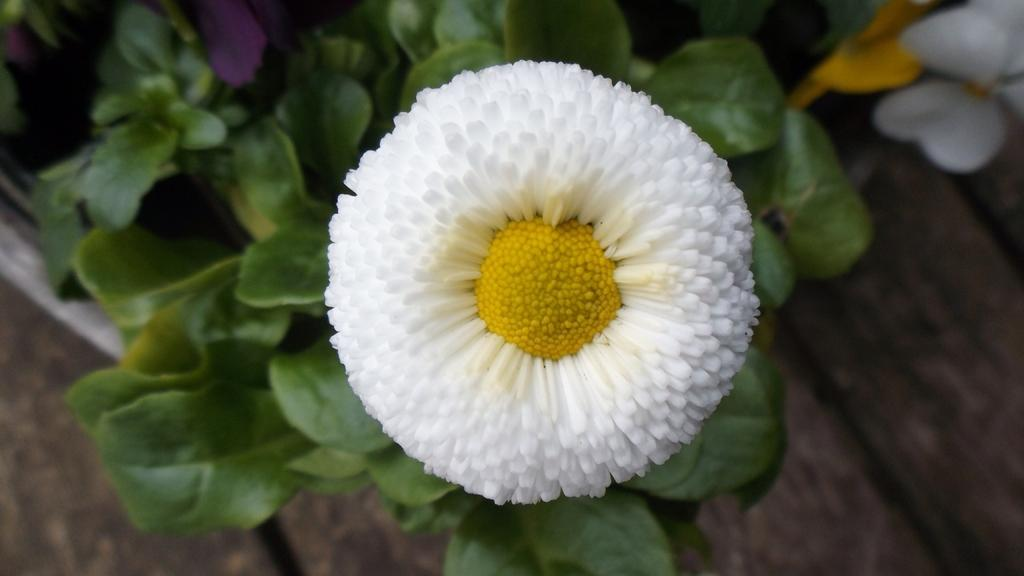What type of plant is in the image? There is a flower in the image. What color is the flower? The flower is white. What part of the flower is green? There are green leaves at the bottom of the flower. What can be seen on the right side of the image? The ground is visible on the right side of the image. Can you describe the car parked near the flower in the image? There is no car present in the image; it features a white flower with green leaves and a visible ground on the right side. 